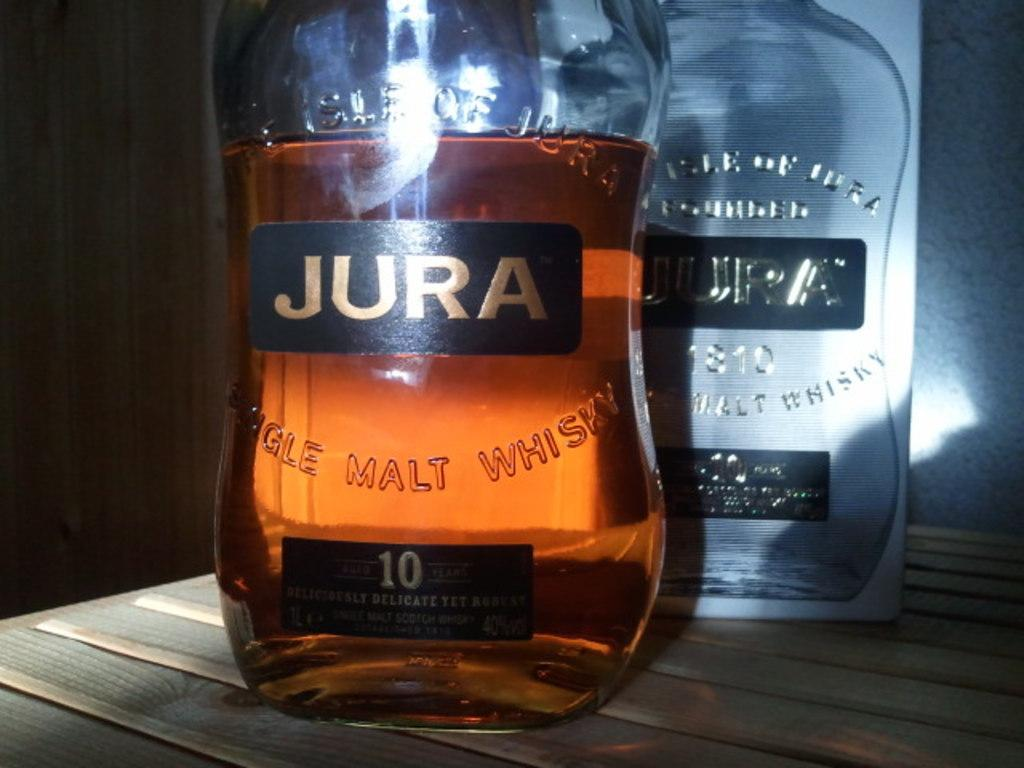<image>
Create a compact narrative representing the image presented. A bottle of Jura malt whiskey sits in front of an empty one. 